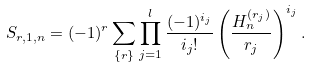<formula> <loc_0><loc_0><loc_500><loc_500>S _ { r , 1 , n } = ( - 1 ) ^ { r } \sum _ { \{ r \} } \prod _ { j = 1 } ^ { l } \frac { ( - 1 ) ^ { i _ { j } } } { i _ { j } ! } \left ( \frac { H _ { n } ^ { ( r _ { j } ) } } { r _ { j } } \right ) ^ { i _ { j } } .</formula> 